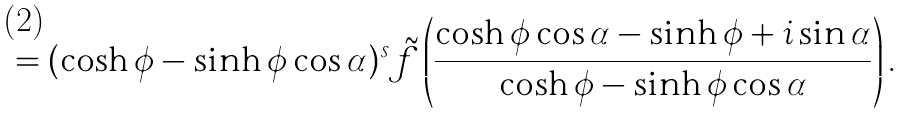Convert formula to latex. <formula><loc_0><loc_0><loc_500><loc_500>= ( \cosh \phi - \sinh \phi \cos \alpha ) ^ { s } \tilde { f } \left ( \frac { \cosh \phi \cos \alpha - \sinh \phi + i \sin \alpha } { \cosh \phi - \sinh \phi \cos \alpha } \right ) .</formula> 